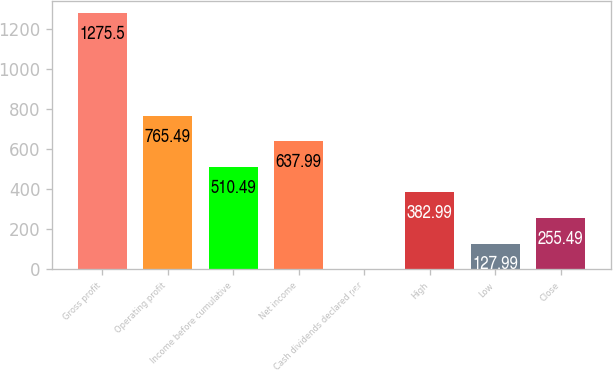Convert chart to OTSL. <chart><loc_0><loc_0><loc_500><loc_500><bar_chart><fcel>Gross profit<fcel>Operating profit<fcel>Income before cumulative<fcel>Net income<fcel>Cash dividends declared per<fcel>High<fcel>Low<fcel>Close<nl><fcel>1275.5<fcel>765.49<fcel>510.49<fcel>637.99<fcel>0.49<fcel>382.99<fcel>127.99<fcel>255.49<nl></chart> 